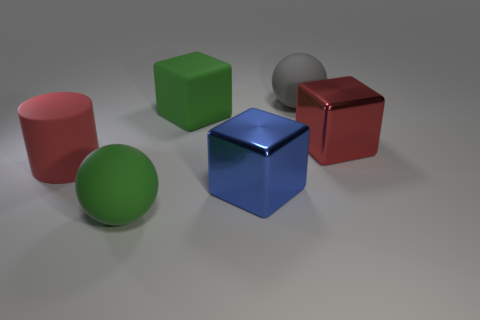Add 3 small yellow metal spheres. How many objects exist? 9 Subtract all spheres. How many objects are left? 4 Add 6 big cylinders. How many big cylinders exist? 7 Subtract 0 blue spheres. How many objects are left? 6 Subtract all gray matte balls. Subtract all cylinders. How many objects are left? 4 Add 1 large red objects. How many large red objects are left? 3 